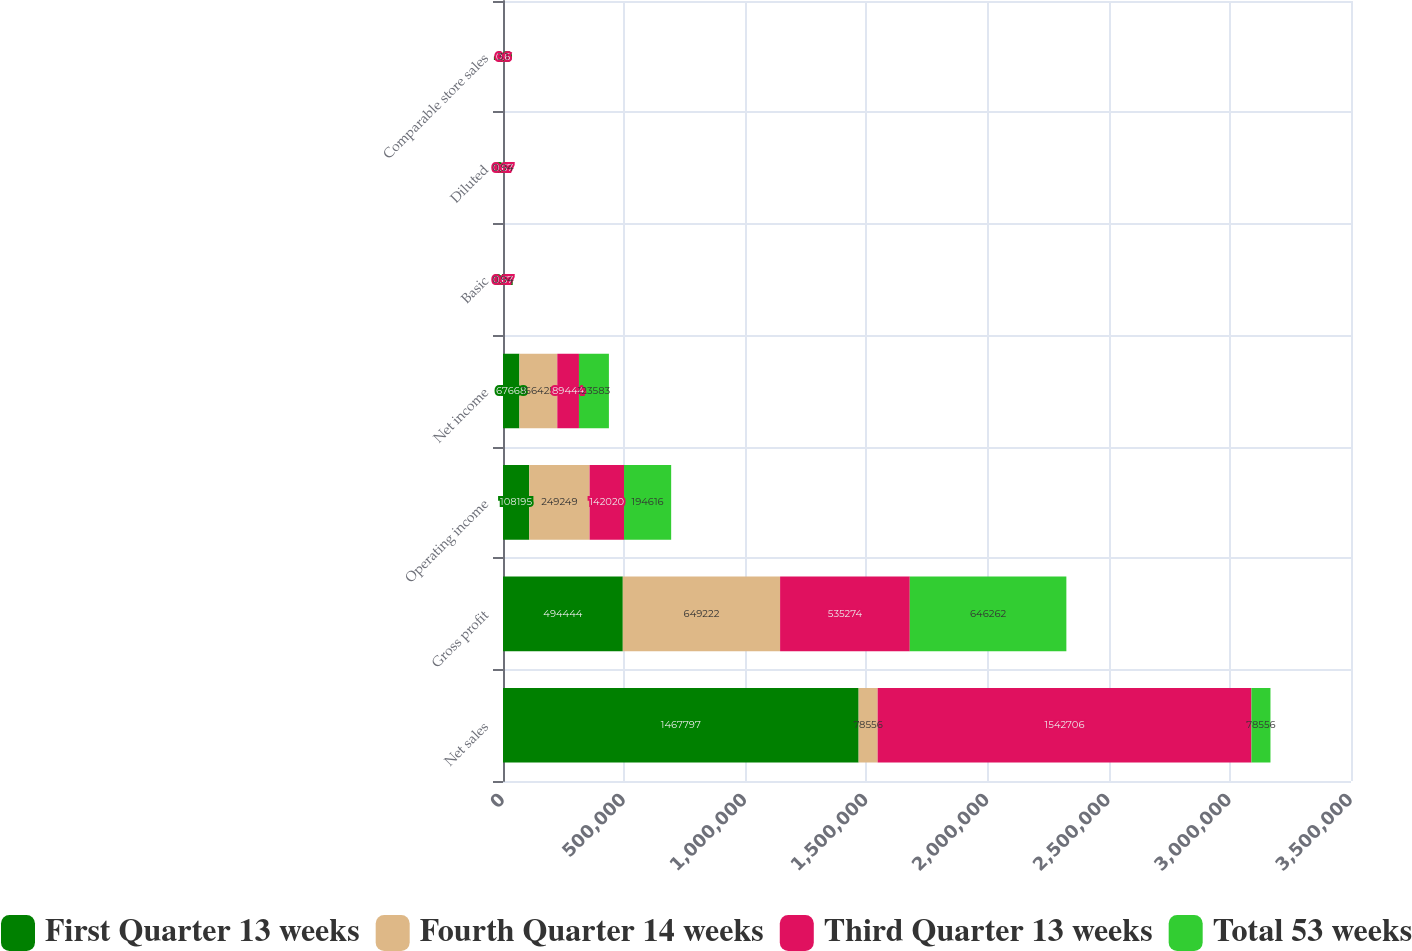Convert chart. <chart><loc_0><loc_0><loc_500><loc_500><stacked_bar_chart><ecel><fcel>Net sales<fcel>Gross profit<fcel>Operating income<fcel>Net income<fcel>Basic<fcel>Diluted<fcel>Comparable store sales<nl><fcel>First Quarter 13 weeks<fcel>1.4678e+06<fcel>494444<fcel>108195<fcel>67668<fcel>0.51<fcel>0.5<fcel>4.9<nl><fcel>Fourth Quarter 14 weeks<fcel>78556<fcel>649222<fcel>249249<fcel>156425<fcel>1.17<fcel>1.16<fcel>0.5<nl><fcel>Third Quarter 13 weeks<fcel>1.54271e+06<fcel>535274<fcel>142020<fcel>89444<fcel>0.67<fcel>0.67<fcel>0.6<nl><fcel>Total 53 weeks<fcel>78556<fcel>646262<fcel>194616<fcel>123583<fcel>0.94<fcel>0.94<fcel>3.1<nl></chart> 